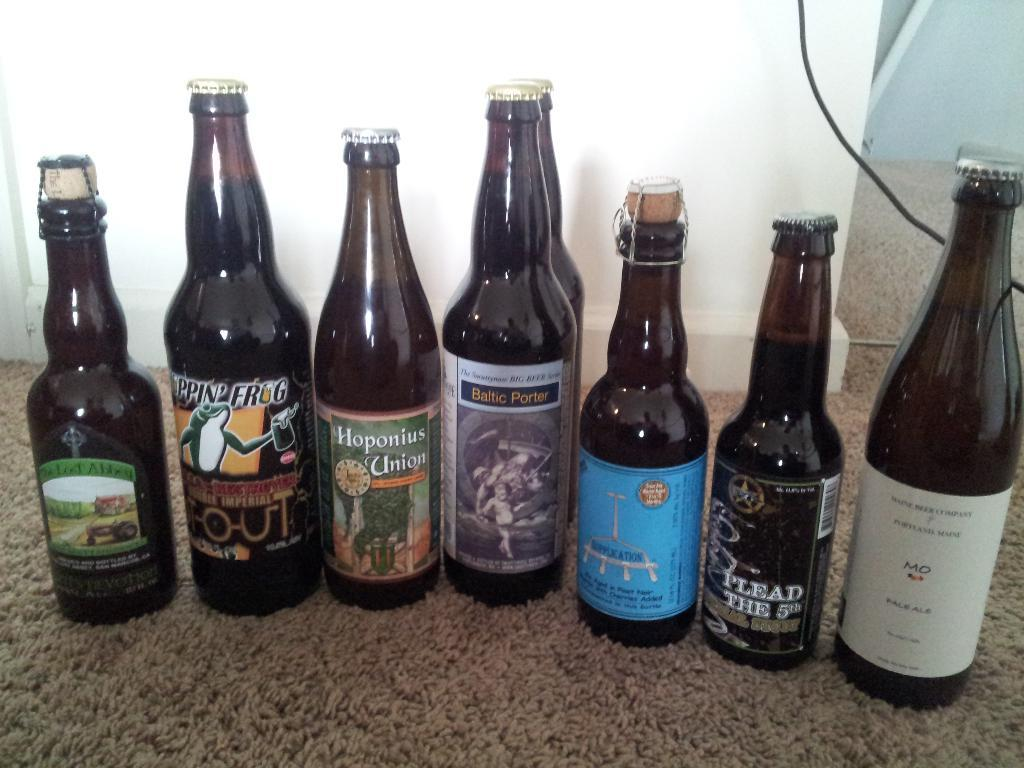Provide a one-sentence caption for the provided image. A bottle of pale ale positioned to the right of six other bottles. 